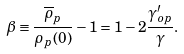Convert formula to latex. <formula><loc_0><loc_0><loc_500><loc_500>\beta \equiv \frac { \overline { \rho } _ { p } } { \rho _ { p } ( 0 ) } - 1 = 1 - 2 \frac { \gamma ^ { \prime } _ { o p } } { \gamma } .</formula> 